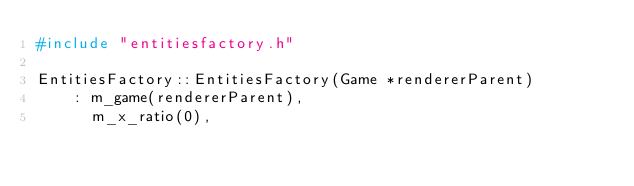Convert code to text. <code><loc_0><loc_0><loc_500><loc_500><_C++_>#include "entitiesfactory.h"

EntitiesFactory::EntitiesFactory(Game *rendererParent)
    : m_game(rendererParent),
      m_x_ratio(0),</code> 